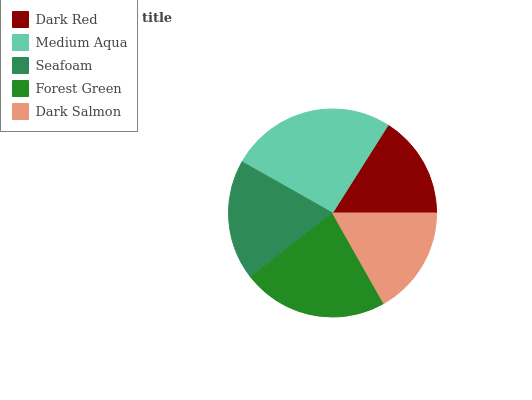Is Dark Red the minimum?
Answer yes or no. Yes. Is Medium Aqua the maximum?
Answer yes or no. Yes. Is Seafoam the minimum?
Answer yes or no. No. Is Seafoam the maximum?
Answer yes or no. No. Is Medium Aqua greater than Seafoam?
Answer yes or no. Yes. Is Seafoam less than Medium Aqua?
Answer yes or no. Yes. Is Seafoam greater than Medium Aqua?
Answer yes or no. No. Is Medium Aqua less than Seafoam?
Answer yes or no. No. Is Seafoam the high median?
Answer yes or no. Yes. Is Seafoam the low median?
Answer yes or no. Yes. Is Dark Red the high median?
Answer yes or no. No. Is Dark Red the low median?
Answer yes or no. No. 